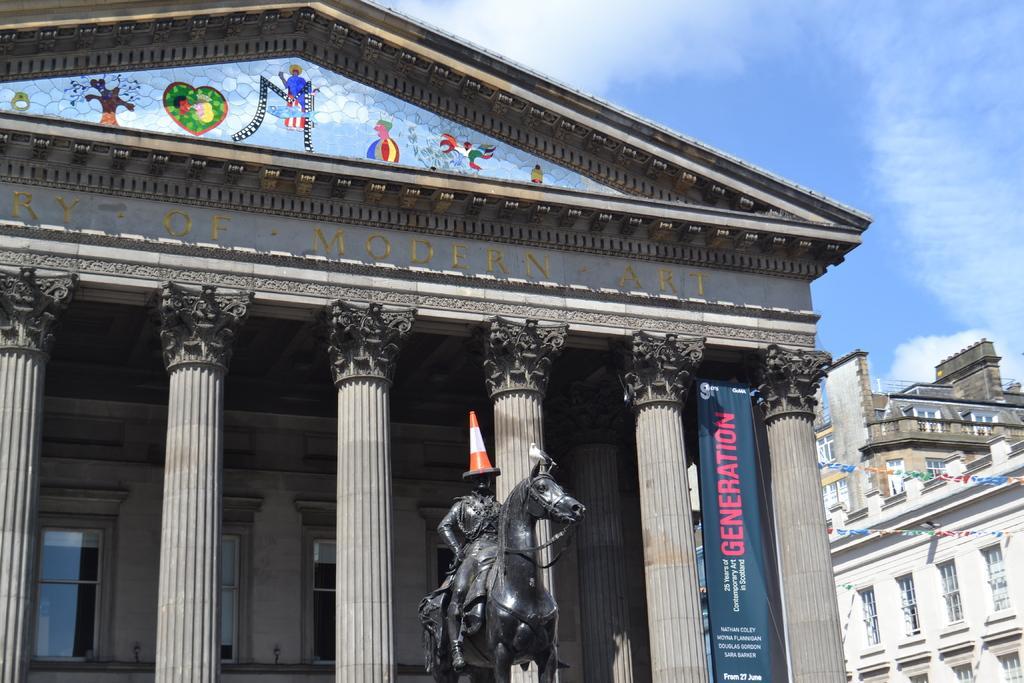In one or two sentences, can you explain what this image depicts? This image consists of a building along with the pillars. In the front, we can see a statue of a man and a horse. At the top, there is a text on the building. At the top, there are clouds in the sky. On the right, there is another building along with windows. 